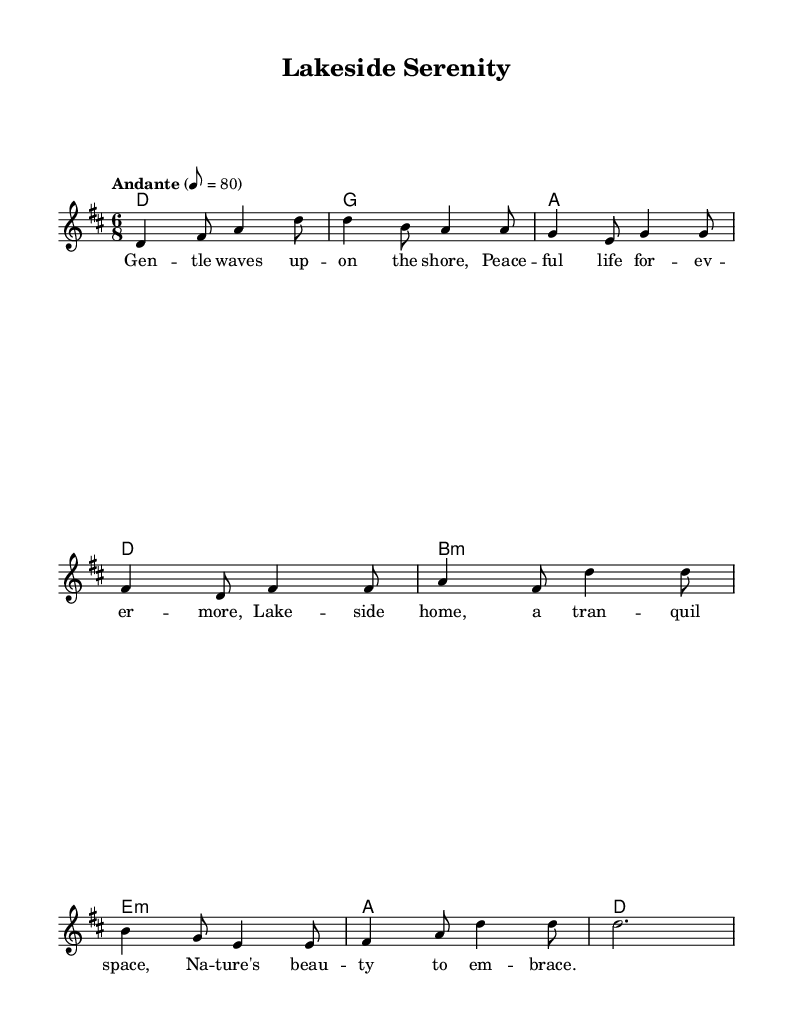What is the key signature of this music? The key signature appears at the beginning of the staff, showing two sharps, which indicate that the piece is in D major.
Answer: D major What is the time signature of this music? The time signature is located at the beginning of the staff, showing a 6/8 signature, indicating that there are six eighth notes per measure.
Answer: 6/8 What is the tempo marking of this piece? The tempo marking "Andante" is prominently placed above the staff, suggesting a moderate pace, with the metronome marking of 80 beats per minute also indicated.
Answer: Andante, 80 How many measures are there in the melody? Counting the measures in the melody section reveals a total of 8 measures present in the music.
Answer: 8 measures What type of chords are used in the harmonies section? The harmonies are represented in chord mode, and include major and minor chords as indicated by the symbols next to the notes, such as m for minor chords.
Answer: Major and minor chords What theme is expressed in the lyrics? Analyzing the lyrics reveals a theme of tranquility and appreciation for nature, especially connected to lakeside living and peacefulness.
Answer: Tranquility, lakeside living Which musical form does this piece resemble? This piece can be categorized as a strophic form, where verses are repeated with the same melody, as indicated by the uniformity of the lyrics set to the melody.
Answer: Strophic form 